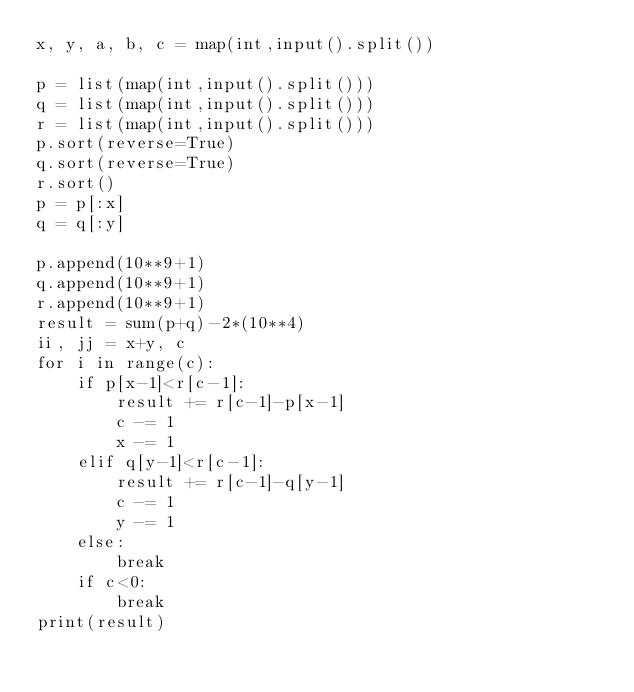Convert code to text. <code><loc_0><loc_0><loc_500><loc_500><_Python_>x, y, a, b, c = map(int,input().split())

p = list(map(int,input().split()))
q = list(map(int,input().split()))
r = list(map(int,input().split()))
p.sort(reverse=True)
q.sort(reverse=True)
r.sort()
p = p[:x]
q = q[:y]

p.append(10**9+1)
q.append(10**9+1)
r.append(10**9+1)
result = sum(p+q)-2*(10**4)
ii, jj = x+y, c
for i in range(c):
    if p[x-1]<r[c-1]:
        result += r[c-1]-p[x-1]
        c -= 1
        x -= 1
    elif q[y-1]<r[c-1]:
        result += r[c-1]-q[y-1]
        c -= 1
        y -= 1
    else:
        break
    if c<0:
        break
print(result)</code> 